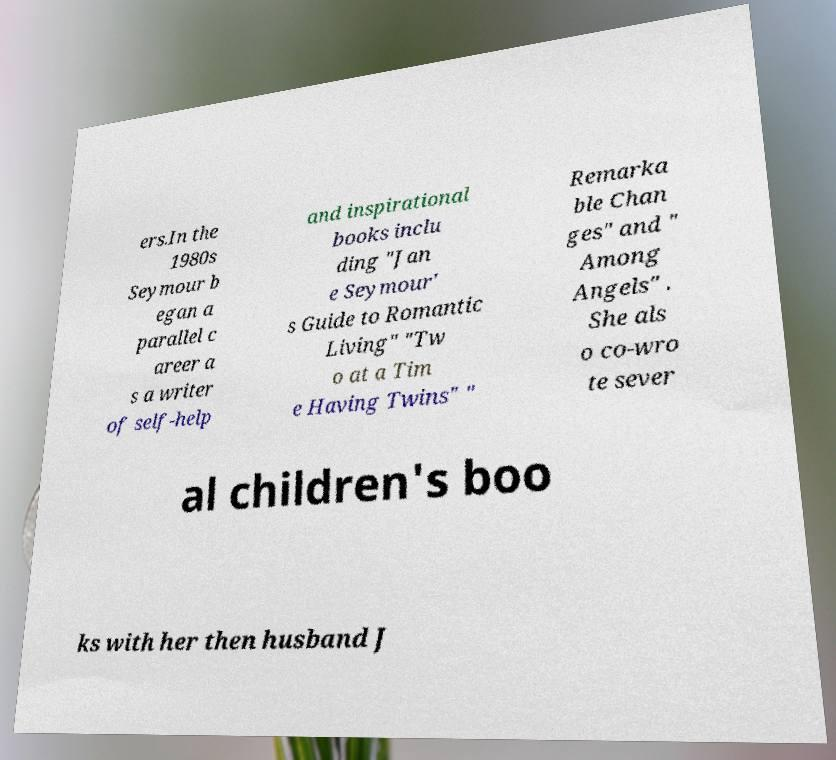Can you read and provide the text displayed in the image?This photo seems to have some interesting text. Can you extract and type it out for me? ers.In the 1980s Seymour b egan a parallel c areer a s a writer of self-help and inspirational books inclu ding "Jan e Seymour' s Guide to Romantic Living" "Tw o at a Tim e Having Twins" " Remarka ble Chan ges" and " Among Angels" . She als o co-wro te sever al children's boo ks with her then husband J 